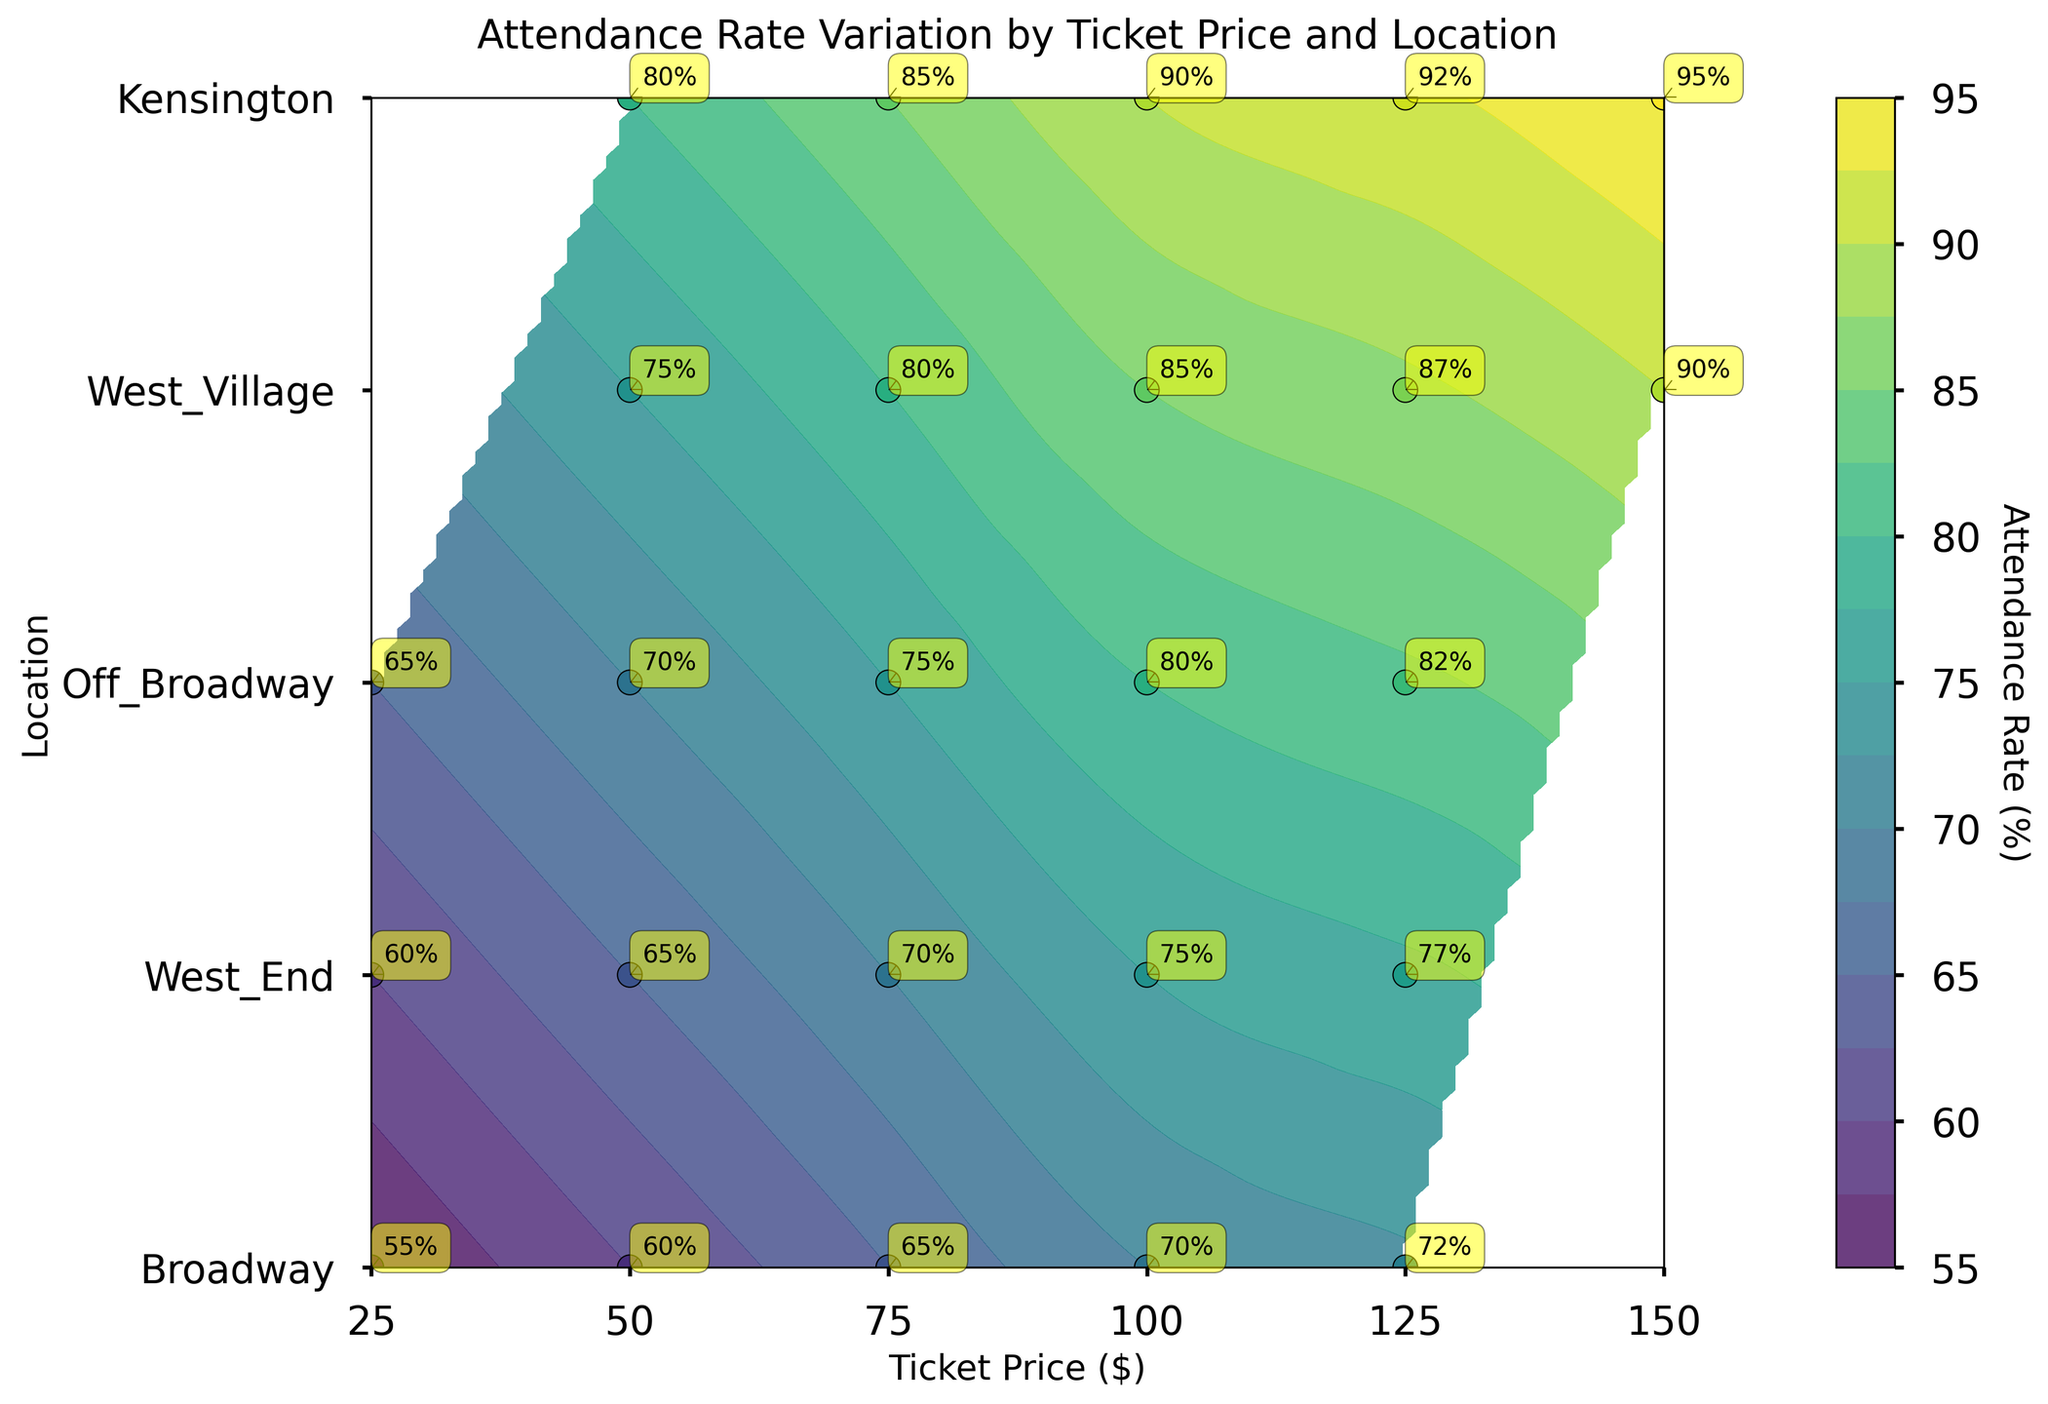What is the maximum Attendance Rate at Kensington? By observing the data points over the "Kensington" region on the y-axis, and their associated labels, note the highest percentage. The maximum Attendance Rate shown is 72%.
Answer: 72% What is the general trend of Attendance Rate as Ticket Price increases at Broadway? Look at the data points labeled "Broadway" and track how the attendance percentages change moving rightward along the x-axis. The Attendance Rate generally increases from 80% to 95% as Ticket Price rises.
Answer: Increases Which location has the lowest Attendance Rate, and what is that rate? Check the y-axis for the lowest data points and their labels, focusing on the lowest percentage mentioned. The lowest rate is 55% at Kensington.
Answer: Kensington, 55% Compare the Attendance Rate at a Ticket Price of $75 between Broadway and West_Village. Which has a higher rate? Focus on the points where the Ticket Price is $75, then compare the labeled attendance rates for "Broadway" and "West_Village". Broadway has 85% and West_Village has 70%, so Broadway is higher.
Answer: Broadway What is the difference in Attendance Rate between the highest and lowest data points? Identify the highest and lowest labeled attendance rates on the plot: highest is 95% (Broadway) and lowest is 55% (Kensington). Subtract to find the difference: 95% - 55% = 40%.
Answer: 40% How does the color of the contours change with higher Attendance Rates? Observe the color gradient used in the plot. The colors shift towards lighter shades as attendance rates increase.
Answer: Lighter At what Ticket Price does West_End achieve an Attendance Rate of 90%? Locate where the "West_End" data points align with a label of 90%, then refer horizontally to the corresponding ticket price.
Answer: $150 Which location has the steepest increase in Attendance Rate between the first two data points (lowest prices)? Compare the Attendance Rate differences between the first two Ticket Prices for each location. Kensington increases from 55% to 60% (a 5% rise), West_Village from 60% to 65% (5%), Off_Broadway from 65% to 70% (5%), West_End from 75% to 80% (5%), and Broadway from 80% to 85% (5%). All locations show an equal steep increase of 5%.
Answer: Equal, 5% What is the average Attendance Rate at Off_Broadway? Sum the Attendance Rates for all the data points at Off_Broadway: 65% + 70% + 75% + 80% + 82%, then divide by the number of points (5). (65 + 70 + 75 + 80 + 82) / 5 = 372 / 5 = 74.4%.
Answer: 74.4% Which two locations have an overlap in their Attendance Rates at multiple Ticket Prices, and what are those rates? Analyze the contour levels and data points where attendance rates match for different locations. Broadway and West_End both have 50% and 75% ticket prices with overlapped Attendance Rates: 80% (at $50) and 85% (at $75).
Answer: Broadway and West_End, at 80% and 85% 